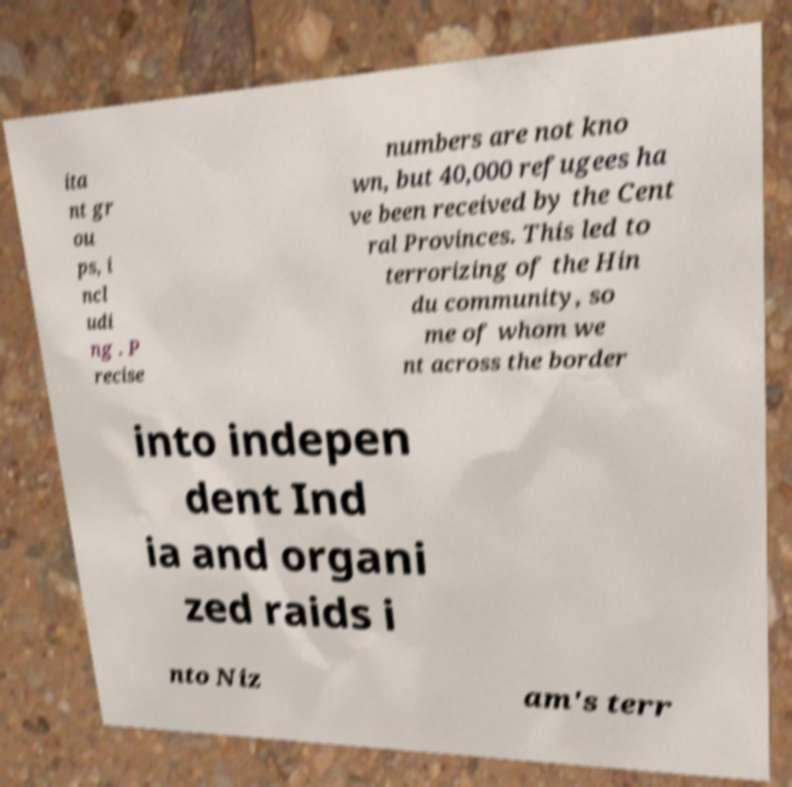I need the written content from this picture converted into text. Can you do that? ita nt gr ou ps, i ncl udi ng . P recise numbers are not kno wn, but 40,000 refugees ha ve been received by the Cent ral Provinces. This led to terrorizing of the Hin du community, so me of whom we nt across the border into indepen dent Ind ia and organi zed raids i nto Niz am's terr 